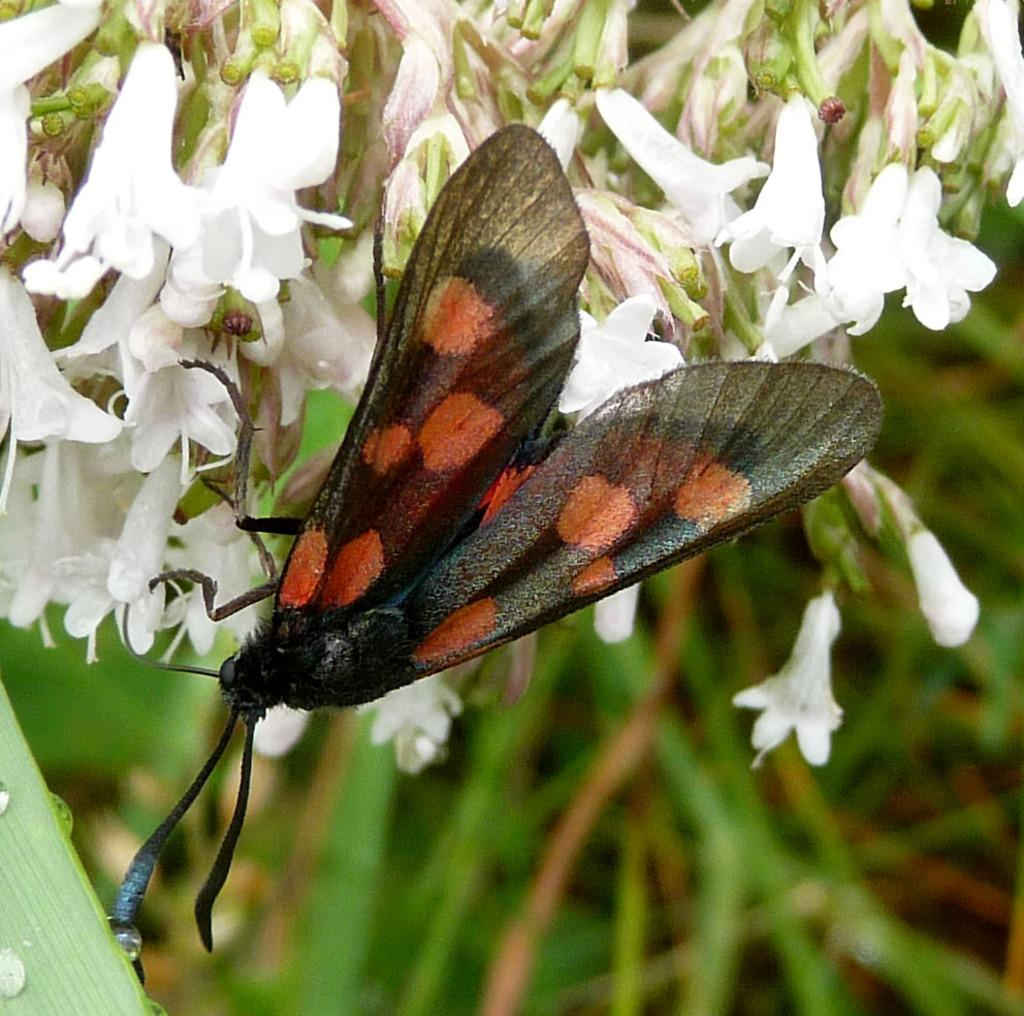What is present in the image? There is a fly in the image. Where is the fly located? The fly is on a flower. What type of apparel is the fly wearing in the image? Flies do not wear apparel, so there is no clothing visible on the fly in the image. 